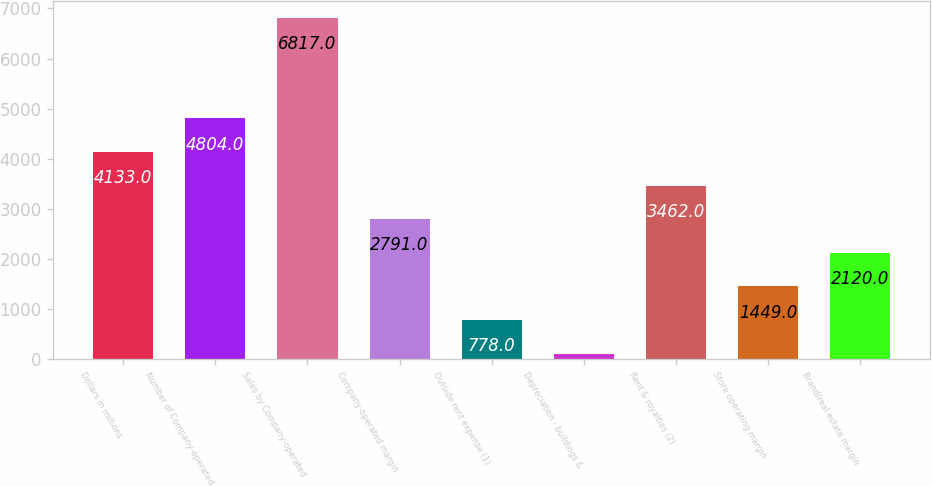Convert chart. <chart><loc_0><loc_0><loc_500><loc_500><bar_chart><fcel>Dollars in millions<fcel>Number of Company-operated<fcel>Sales by Company-operated<fcel>Company-operated margin<fcel>Outside rent expense (1)<fcel>Depreciation - buildings &<fcel>Rent & royalties (2)<fcel>Store operating margin<fcel>Brand/real estate margin<nl><fcel>4133<fcel>4804<fcel>6817<fcel>2791<fcel>778<fcel>107<fcel>3462<fcel>1449<fcel>2120<nl></chart> 